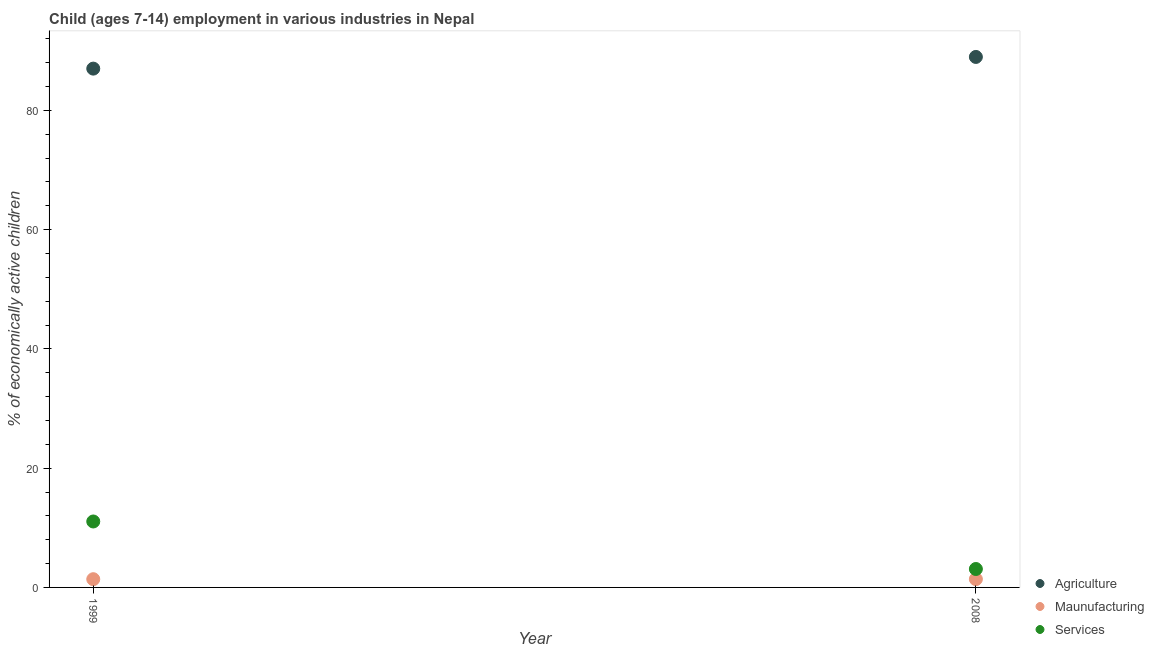How many different coloured dotlines are there?
Give a very brief answer. 3. Is the number of dotlines equal to the number of legend labels?
Your answer should be compact. Yes. What is the percentage of economically active children in services in 2008?
Your answer should be very brief. 3.09. Across all years, what is the maximum percentage of economically active children in services?
Your answer should be compact. 11.06. Across all years, what is the minimum percentage of economically active children in services?
Make the answer very short. 3.09. In which year was the percentage of economically active children in services maximum?
Your answer should be very brief. 1999. In which year was the percentage of economically active children in agriculture minimum?
Make the answer very short. 1999. What is the total percentage of economically active children in agriculture in the graph?
Your answer should be very brief. 175.98. What is the difference between the percentage of economically active children in agriculture in 1999 and that in 2008?
Give a very brief answer. -1.96. What is the difference between the percentage of economically active children in agriculture in 1999 and the percentage of economically active children in services in 2008?
Offer a terse response. 83.92. What is the average percentage of economically active children in agriculture per year?
Make the answer very short. 87.99. In the year 1999, what is the difference between the percentage of economically active children in agriculture and percentage of economically active children in services?
Offer a very short reply. 75.95. What is the ratio of the percentage of economically active children in agriculture in 1999 to that in 2008?
Make the answer very short. 0.98. Is the percentage of economically active children in agriculture in 1999 less than that in 2008?
Provide a short and direct response. Yes. In how many years, is the percentage of economically active children in agriculture greater than the average percentage of economically active children in agriculture taken over all years?
Offer a terse response. 1. Is the percentage of economically active children in services strictly greater than the percentage of economically active children in agriculture over the years?
Give a very brief answer. No. How many years are there in the graph?
Offer a very short reply. 2. What is the difference between two consecutive major ticks on the Y-axis?
Give a very brief answer. 20. Does the graph contain grids?
Your answer should be very brief. No. How many legend labels are there?
Provide a short and direct response. 3. How are the legend labels stacked?
Your response must be concise. Vertical. What is the title of the graph?
Your answer should be compact. Child (ages 7-14) employment in various industries in Nepal. Does "Infant(male)" appear as one of the legend labels in the graph?
Your answer should be compact. No. What is the label or title of the Y-axis?
Offer a terse response. % of economically active children. What is the % of economically active children of Agriculture in 1999?
Your answer should be very brief. 87.01. What is the % of economically active children of Maunufacturing in 1999?
Your response must be concise. 1.38. What is the % of economically active children of Services in 1999?
Your answer should be compact. 11.06. What is the % of economically active children in Agriculture in 2008?
Provide a short and direct response. 88.97. What is the % of economically active children in Maunufacturing in 2008?
Offer a terse response. 1.39. What is the % of economically active children in Services in 2008?
Your answer should be very brief. 3.09. Across all years, what is the maximum % of economically active children of Agriculture?
Give a very brief answer. 88.97. Across all years, what is the maximum % of economically active children in Maunufacturing?
Your answer should be compact. 1.39. Across all years, what is the maximum % of economically active children of Services?
Give a very brief answer. 11.06. Across all years, what is the minimum % of economically active children of Agriculture?
Offer a terse response. 87.01. Across all years, what is the minimum % of economically active children of Maunufacturing?
Provide a succinct answer. 1.38. Across all years, what is the minimum % of economically active children in Services?
Your response must be concise. 3.09. What is the total % of economically active children of Agriculture in the graph?
Offer a very short reply. 175.98. What is the total % of economically active children in Maunufacturing in the graph?
Offer a terse response. 2.77. What is the total % of economically active children in Services in the graph?
Give a very brief answer. 14.15. What is the difference between the % of economically active children in Agriculture in 1999 and that in 2008?
Your answer should be very brief. -1.96. What is the difference between the % of economically active children in Maunufacturing in 1999 and that in 2008?
Make the answer very short. -0.01. What is the difference between the % of economically active children of Services in 1999 and that in 2008?
Offer a very short reply. 7.97. What is the difference between the % of economically active children of Agriculture in 1999 and the % of economically active children of Maunufacturing in 2008?
Your answer should be compact. 85.62. What is the difference between the % of economically active children in Agriculture in 1999 and the % of economically active children in Services in 2008?
Keep it short and to the point. 83.92. What is the difference between the % of economically active children in Maunufacturing in 1999 and the % of economically active children in Services in 2008?
Your response must be concise. -1.71. What is the average % of economically active children in Agriculture per year?
Ensure brevity in your answer.  87.99. What is the average % of economically active children of Maunufacturing per year?
Make the answer very short. 1.39. What is the average % of economically active children of Services per year?
Your answer should be very brief. 7.08. In the year 1999, what is the difference between the % of economically active children in Agriculture and % of economically active children in Maunufacturing?
Provide a succinct answer. 85.63. In the year 1999, what is the difference between the % of economically active children in Agriculture and % of economically active children in Services?
Offer a very short reply. 75.95. In the year 1999, what is the difference between the % of economically active children of Maunufacturing and % of economically active children of Services?
Ensure brevity in your answer.  -9.68. In the year 2008, what is the difference between the % of economically active children in Agriculture and % of economically active children in Maunufacturing?
Your answer should be compact. 87.58. In the year 2008, what is the difference between the % of economically active children in Agriculture and % of economically active children in Services?
Provide a short and direct response. 85.88. What is the ratio of the % of economically active children of Agriculture in 1999 to that in 2008?
Give a very brief answer. 0.98. What is the ratio of the % of economically active children in Services in 1999 to that in 2008?
Give a very brief answer. 3.58. What is the difference between the highest and the second highest % of economically active children in Agriculture?
Give a very brief answer. 1.96. What is the difference between the highest and the second highest % of economically active children in Maunufacturing?
Offer a terse response. 0.01. What is the difference between the highest and the second highest % of economically active children in Services?
Offer a very short reply. 7.97. What is the difference between the highest and the lowest % of economically active children in Agriculture?
Offer a terse response. 1.96. What is the difference between the highest and the lowest % of economically active children in Maunufacturing?
Offer a very short reply. 0.01. What is the difference between the highest and the lowest % of economically active children of Services?
Your answer should be very brief. 7.97. 